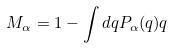<formula> <loc_0><loc_0><loc_500><loc_500>M _ { \alpha } = 1 - \int d q P _ { \alpha } ( q ) q</formula> 